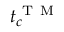<formula> <loc_0><loc_0><loc_500><loc_500>t _ { c } ^ { T M }</formula> 